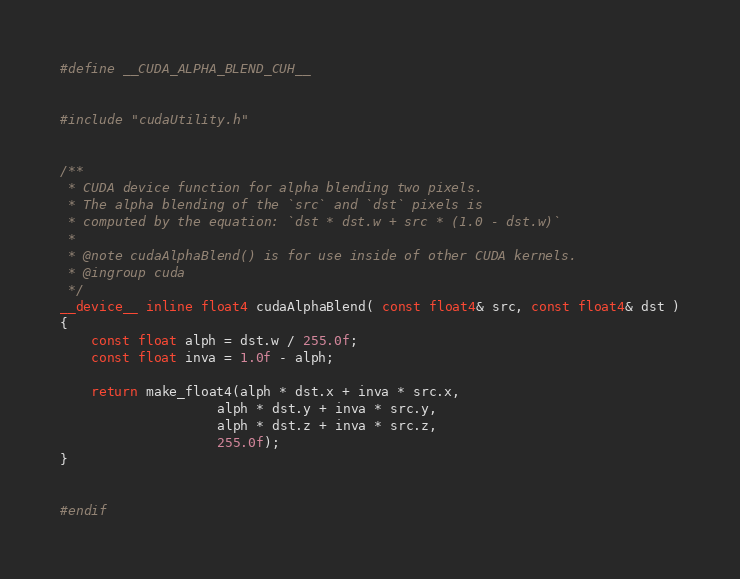Convert code to text. <code><loc_0><loc_0><loc_500><loc_500><_Cuda_>#define __CUDA_ALPHA_BLEND_CUH__


#include "cudaUtility.h"


/**
 * CUDA device function for alpha blending two pixels.
 * The alpha blending of the `src` and `dst` pixels is
 * computed by the equation: `dst * dst.w + src * (1.0 - dst.w)`
 *
 * @note cudaAlphaBlend() is for use inside of other CUDA kernels.
 * @ingroup cuda
 */
__device__ inline float4 cudaAlphaBlend( const float4& src, const float4& dst )
{
	const float alph = dst.w / 255.0f;
	const float inva = 1.0f - alph;

	return make_float4(alph * dst.x + inva * src.x,
				    alph * dst.y + inva * src.y,
				    alph * dst.z + inva * src.z,
				    255.0f);
}


#endif


</code> 